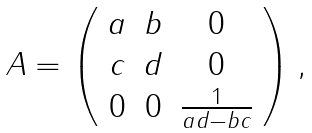Convert formula to latex. <formula><loc_0><loc_0><loc_500><loc_500>\begin{array} { l l l l l l l } A = \left ( \begin{array} { c c c } a & b & 0 \\ c & d & 0 \\ 0 & 0 & \frac { 1 } { a d - b c } \end{array} \right ) , \end{array}</formula> 